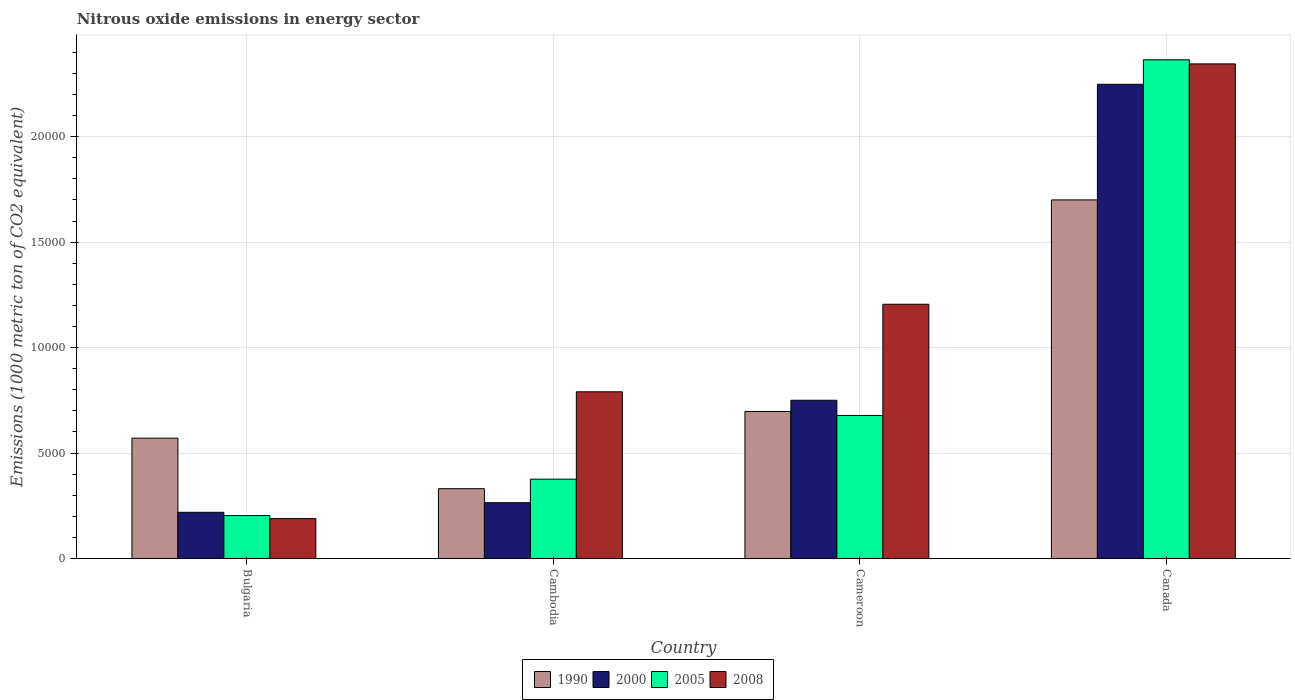Are the number of bars per tick equal to the number of legend labels?
Provide a succinct answer. Yes. How many bars are there on the 2nd tick from the right?
Give a very brief answer. 4. What is the amount of nitrous oxide emitted in 1990 in Bulgaria?
Provide a short and direct response. 5705.4. Across all countries, what is the maximum amount of nitrous oxide emitted in 2005?
Provide a succinct answer. 2.36e+04. Across all countries, what is the minimum amount of nitrous oxide emitted in 2008?
Ensure brevity in your answer.  1890.6. In which country was the amount of nitrous oxide emitted in 2008 maximum?
Your answer should be very brief. Canada. In which country was the amount of nitrous oxide emitted in 2000 minimum?
Give a very brief answer. Bulgaria. What is the total amount of nitrous oxide emitted in 2005 in the graph?
Your answer should be compact. 3.62e+04. What is the difference between the amount of nitrous oxide emitted in 1990 in Bulgaria and that in Canada?
Provide a short and direct response. -1.13e+04. What is the difference between the amount of nitrous oxide emitted in 2005 in Cameroon and the amount of nitrous oxide emitted in 2008 in Cambodia?
Provide a short and direct response. -1120.8. What is the average amount of nitrous oxide emitted in 1990 per country?
Make the answer very short. 8246.02. What is the difference between the amount of nitrous oxide emitted of/in 2005 and amount of nitrous oxide emitted of/in 2008 in Cameroon?
Give a very brief answer. -5271. What is the ratio of the amount of nitrous oxide emitted in 2000 in Bulgaria to that in Canada?
Your answer should be very brief. 0.1. What is the difference between the highest and the second highest amount of nitrous oxide emitted in 2008?
Your response must be concise. 1.14e+04. What is the difference between the highest and the lowest amount of nitrous oxide emitted in 1990?
Offer a very short reply. 1.37e+04. Is it the case that in every country, the sum of the amount of nitrous oxide emitted in 2000 and amount of nitrous oxide emitted in 2008 is greater than the sum of amount of nitrous oxide emitted in 2005 and amount of nitrous oxide emitted in 1990?
Give a very brief answer. No. What does the 1st bar from the left in Cambodia represents?
Keep it short and to the point. 1990. Is it the case that in every country, the sum of the amount of nitrous oxide emitted in 2008 and amount of nitrous oxide emitted in 2000 is greater than the amount of nitrous oxide emitted in 2005?
Provide a succinct answer. Yes. How many bars are there?
Your answer should be very brief. 16. Are all the bars in the graph horizontal?
Keep it short and to the point. No. How many countries are there in the graph?
Make the answer very short. 4. Are the values on the major ticks of Y-axis written in scientific E-notation?
Ensure brevity in your answer.  No. Does the graph contain any zero values?
Offer a very short reply. No. Does the graph contain grids?
Your answer should be very brief. Yes. Where does the legend appear in the graph?
Provide a short and direct response. Bottom center. How many legend labels are there?
Keep it short and to the point. 4. How are the legend labels stacked?
Give a very brief answer. Horizontal. What is the title of the graph?
Keep it short and to the point. Nitrous oxide emissions in energy sector. What is the label or title of the X-axis?
Give a very brief answer. Country. What is the label or title of the Y-axis?
Make the answer very short. Emissions (1000 metric ton of CO2 equivalent). What is the Emissions (1000 metric ton of CO2 equivalent) in 1990 in Bulgaria?
Offer a terse response. 5705.4. What is the Emissions (1000 metric ton of CO2 equivalent) in 2000 in Bulgaria?
Your answer should be compact. 2189.9. What is the Emissions (1000 metric ton of CO2 equivalent) in 2005 in Bulgaria?
Provide a short and direct response. 2033.5. What is the Emissions (1000 metric ton of CO2 equivalent) in 2008 in Bulgaria?
Give a very brief answer. 1890.6. What is the Emissions (1000 metric ton of CO2 equivalent) of 1990 in Cambodia?
Your response must be concise. 3309.2. What is the Emissions (1000 metric ton of CO2 equivalent) in 2000 in Cambodia?
Your answer should be very brief. 2644.9. What is the Emissions (1000 metric ton of CO2 equivalent) in 2005 in Cambodia?
Make the answer very short. 3761.1. What is the Emissions (1000 metric ton of CO2 equivalent) of 2008 in Cambodia?
Offer a terse response. 7902.7. What is the Emissions (1000 metric ton of CO2 equivalent) in 1990 in Cameroon?
Your answer should be compact. 6970.1. What is the Emissions (1000 metric ton of CO2 equivalent) in 2000 in Cameroon?
Your response must be concise. 7501.6. What is the Emissions (1000 metric ton of CO2 equivalent) of 2005 in Cameroon?
Provide a succinct answer. 6781.9. What is the Emissions (1000 metric ton of CO2 equivalent) in 2008 in Cameroon?
Keep it short and to the point. 1.21e+04. What is the Emissions (1000 metric ton of CO2 equivalent) of 1990 in Canada?
Your response must be concise. 1.70e+04. What is the Emissions (1000 metric ton of CO2 equivalent) of 2000 in Canada?
Your answer should be compact. 2.25e+04. What is the Emissions (1000 metric ton of CO2 equivalent) of 2005 in Canada?
Make the answer very short. 2.36e+04. What is the Emissions (1000 metric ton of CO2 equivalent) of 2008 in Canada?
Provide a succinct answer. 2.34e+04. Across all countries, what is the maximum Emissions (1000 metric ton of CO2 equivalent) of 1990?
Make the answer very short. 1.70e+04. Across all countries, what is the maximum Emissions (1000 metric ton of CO2 equivalent) of 2000?
Offer a terse response. 2.25e+04. Across all countries, what is the maximum Emissions (1000 metric ton of CO2 equivalent) of 2005?
Give a very brief answer. 2.36e+04. Across all countries, what is the maximum Emissions (1000 metric ton of CO2 equivalent) of 2008?
Give a very brief answer. 2.34e+04. Across all countries, what is the minimum Emissions (1000 metric ton of CO2 equivalent) in 1990?
Give a very brief answer. 3309.2. Across all countries, what is the minimum Emissions (1000 metric ton of CO2 equivalent) in 2000?
Your response must be concise. 2189.9. Across all countries, what is the minimum Emissions (1000 metric ton of CO2 equivalent) in 2005?
Your answer should be very brief. 2033.5. Across all countries, what is the minimum Emissions (1000 metric ton of CO2 equivalent) in 2008?
Make the answer very short. 1890.6. What is the total Emissions (1000 metric ton of CO2 equivalent) of 1990 in the graph?
Your answer should be compact. 3.30e+04. What is the total Emissions (1000 metric ton of CO2 equivalent) in 2000 in the graph?
Your response must be concise. 3.48e+04. What is the total Emissions (1000 metric ton of CO2 equivalent) in 2005 in the graph?
Ensure brevity in your answer.  3.62e+04. What is the total Emissions (1000 metric ton of CO2 equivalent) in 2008 in the graph?
Make the answer very short. 4.53e+04. What is the difference between the Emissions (1000 metric ton of CO2 equivalent) of 1990 in Bulgaria and that in Cambodia?
Your answer should be very brief. 2396.2. What is the difference between the Emissions (1000 metric ton of CO2 equivalent) in 2000 in Bulgaria and that in Cambodia?
Your answer should be compact. -455. What is the difference between the Emissions (1000 metric ton of CO2 equivalent) in 2005 in Bulgaria and that in Cambodia?
Keep it short and to the point. -1727.6. What is the difference between the Emissions (1000 metric ton of CO2 equivalent) in 2008 in Bulgaria and that in Cambodia?
Provide a succinct answer. -6012.1. What is the difference between the Emissions (1000 metric ton of CO2 equivalent) in 1990 in Bulgaria and that in Cameroon?
Your answer should be very brief. -1264.7. What is the difference between the Emissions (1000 metric ton of CO2 equivalent) in 2000 in Bulgaria and that in Cameroon?
Give a very brief answer. -5311.7. What is the difference between the Emissions (1000 metric ton of CO2 equivalent) in 2005 in Bulgaria and that in Cameroon?
Keep it short and to the point. -4748.4. What is the difference between the Emissions (1000 metric ton of CO2 equivalent) of 2008 in Bulgaria and that in Cameroon?
Your answer should be very brief. -1.02e+04. What is the difference between the Emissions (1000 metric ton of CO2 equivalent) of 1990 in Bulgaria and that in Canada?
Keep it short and to the point. -1.13e+04. What is the difference between the Emissions (1000 metric ton of CO2 equivalent) in 2000 in Bulgaria and that in Canada?
Your answer should be compact. -2.03e+04. What is the difference between the Emissions (1000 metric ton of CO2 equivalent) in 2005 in Bulgaria and that in Canada?
Offer a very short reply. -2.16e+04. What is the difference between the Emissions (1000 metric ton of CO2 equivalent) in 2008 in Bulgaria and that in Canada?
Your answer should be very brief. -2.16e+04. What is the difference between the Emissions (1000 metric ton of CO2 equivalent) in 1990 in Cambodia and that in Cameroon?
Offer a terse response. -3660.9. What is the difference between the Emissions (1000 metric ton of CO2 equivalent) of 2000 in Cambodia and that in Cameroon?
Make the answer very short. -4856.7. What is the difference between the Emissions (1000 metric ton of CO2 equivalent) of 2005 in Cambodia and that in Cameroon?
Keep it short and to the point. -3020.8. What is the difference between the Emissions (1000 metric ton of CO2 equivalent) of 2008 in Cambodia and that in Cameroon?
Give a very brief answer. -4150.2. What is the difference between the Emissions (1000 metric ton of CO2 equivalent) of 1990 in Cambodia and that in Canada?
Provide a short and direct response. -1.37e+04. What is the difference between the Emissions (1000 metric ton of CO2 equivalent) in 2000 in Cambodia and that in Canada?
Your answer should be very brief. -1.98e+04. What is the difference between the Emissions (1000 metric ton of CO2 equivalent) of 2005 in Cambodia and that in Canada?
Offer a very short reply. -1.99e+04. What is the difference between the Emissions (1000 metric ton of CO2 equivalent) of 2008 in Cambodia and that in Canada?
Offer a very short reply. -1.55e+04. What is the difference between the Emissions (1000 metric ton of CO2 equivalent) of 1990 in Cameroon and that in Canada?
Your response must be concise. -1.00e+04. What is the difference between the Emissions (1000 metric ton of CO2 equivalent) in 2000 in Cameroon and that in Canada?
Offer a terse response. -1.50e+04. What is the difference between the Emissions (1000 metric ton of CO2 equivalent) in 2005 in Cameroon and that in Canada?
Your answer should be compact. -1.69e+04. What is the difference between the Emissions (1000 metric ton of CO2 equivalent) of 2008 in Cameroon and that in Canada?
Ensure brevity in your answer.  -1.14e+04. What is the difference between the Emissions (1000 metric ton of CO2 equivalent) of 1990 in Bulgaria and the Emissions (1000 metric ton of CO2 equivalent) of 2000 in Cambodia?
Your response must be concise. 3060.5. What is the difference between the Emissions (1000 metric ton of CO2 equivalent) of 1990 in Bulgaria and the Emissions (1000 metric ton of CO2 equivalent) of 2005 in Cambodia?
Give a very brief answer. 1944.3. What is the difference between the Emissions (1000 metric ton of CO2 equivalent) of 1990 in Bulgaria and the Emissions (1000 metric ton of CO2 equivalent) of 2008 in Cambodia?
Offer a very short reply. -2197.3. What is the difference between the Emissions (1000 metric ton of CO2 equivalent) of 2000 in Bulgaria and the Emissions (1000 metric ton of CO2 equivalent) of 2005 in Cambodia?
Offer a very short reply. -1571.2. What is the difference between the Emissions (1000 metric ton of CO2 equivalent) of 2000 in Bulgaria and the Emissions (1000 metric ton of CO2 equivalent) of 2008 in Cambodia?
Make the answer very short. -5712.8. What is the difference between the Emissions (1000 metric ton of CO2 equivalent) of 2005 in Bulgaria and the Emissions (1000 metric ton of CO2 equivalent) of 2008 in Cambodia?
Your answer should be compact. -5869.2. What is the difference between the Emissions (1000 metric ton of CO2 equivalent) in 1990 in Bulgaria and the Emissions (1000 metric ton of CO2 equivalent) in 2000 in Cameroon?
Make the answer very short. -1796.2. What is the difference between the Emissions (1000 metric ton of CO2 equivalent) in 1990 in Bulgaria and the Emissions (1000 metric ton of CO2 equivalent) in 2005 in Cameroon?
Your answer should be compact. -1076.5. What is the difference between the Emissions (1000 metric ton of CO2 equivalent) of 1990 in Bulgaria and the Emissions (1000 metric ton of CO2 equivalent) of 2008 in Cameroon?
Ensure brevity in your answer.  -6347.5. What is the difference between the Emissions (1000 metric ton of CO2 equivalent) in 2000 in Bulgaria and the Emissions (1000 metric ton of CO2 equivalent) in 2005 in Cameroon?
Your answer should be compact. -4592. What is the difference between the Emissions (1000 metric ton of CO2 equivalent) of 2000 in Bulgaria and the Emissions (1000 metric ton of CO2 equivalent) of 2008 in Cameroon?
Keep it short and to the point. -9863. What is the difference between the Emissions (1000 metric ton of CO2 equivalent) of 2005 in Bulgaria and the Emissions (1000 metric ton of CO2 equivalent) of 2008 in Cameroon?
Offer a very short reply. -1.00e+04. What is the difference between the Emissions (1000 metric ton of CO2 equivalent) of 1990 in Bulgaria and the Emissions (1000 metric ton of CO2 equivalent) of 2000 in Canada?
Provide a short and direct response. -1.68e+04. What is the difference between the Emissions (1000 metric ton of CO2 equivalent) in 1990 in Bulgaria and the Emissions (1000 metric ton of CO2 equivalent) in 2005 in Canada?
Provide a succinct answer. -1.79e+04. What is the difference between the Emissions (1000 metric ton of CO2 equivalent) in 1990 in Bulgaria and the Emissions (1000 metric ton of CO2 equivalent) in 2008 in Canada?
Your answer should be very brief. -1.77e+04. What is the difference between the Emissions (1000 metric ton of CO2 equivalent) of 2000 in Bulgaria and the Emissions (1000 metric ton of CO2 equivalent) of 2005 in Canada?
Your answer should be compact. -2.15e+04. What is the difference between the Emissions (1000 metric ton of CO2 equivalent) of 2000 in Bulgaria and the Emissions (1000 metric ton of CO2 equivalent) of 2008 in Canada?
Keep it short and to the point. -2.13e+04. What is the difference between the Emissions (1000 metric ton of CO2 equivalent) of 2005 in Bulgaria and the Emissions (1000 metric ton of CO2 equivalent) of 2008 in Canada?
Your answer should be compact. -2.14e+04. What is the difference between the Emissions (1000 metric ton of CO2 equivalent) of 1990 in Cambodia and the Emissions (1000 metric ton of CO2 equivalent) of 2000 in Cameroon?
Your answer should be very brief. -4192.4. What is the difference between the Emissions (1000 metric ton of CO2 equivalent) in 1990 in Cambodia and the Emissions (1000 metric ton of CO2 equivalent) in 2005 in Cameroon?
Make the answer very short. -3472.7. What is the difference between the Emissions (1000 metric ton of CO2 equivalent) of 1990 in Cambodia and the Emissions (1000 metric ton of CO2 equivalent) of 2008 in Cameroon?
Make the answer very short. -8743.7. What is the difference between the Emissions (1000 metric ton of CO2 equivalent) of 2000 in Cambodia and the Emissions (1000 metric ton of CO2 equivalent) of 2005 in Cameroon?
Keep it short and to the point. -4137. What is the difference between the Emissions (1000 metric ton of CO2 equivalent) of 2000 in Cambodia and the Emissions (1000 metric ton of CO2 equivalent) of 2008 in Cameroon?
Offer a very short reply. -9408. What is the difference between the Emissions (1000 metric ton of CO2 equivalent) of 2005 in Cambodia and the Emissions (1000 metric ton of CO2 equivalent) of 2008 in Cameroon?
Your response must be concise. -8291.8. What is the difference between the Emissions (1000 metric ton of CO2 equivalent) of 1990 in Cambodia and the Emissions (1000 metric ton of CO2 equivalent) of 2000 in Canada?
Provide a short and direct response. -1.92e+04. What is the difference between the Emissions (1000 metric ton of CO2 equivalent) in 1990 in Cambodia and the Emissions (1000 metric ton of CO2 equivalent) in 2005 in Canada?
Provide a succinct answer. -2.03e+04. What is the difference between the Emissions (1000 metric ton of CO2 equivalent) of 1990 in Cambodia and the Emissions (1000 metric ton of CO2 equivalent) of 2008 in Canada?
Your answer should be very brief. -2.01e+04. What is the difference between the Emissions (1000 metric ton of CO2 equivalent) in 2000 in Cambodia and the Emissions (1000 metric ton of CO2 equivalent) in 2005 in Canada?
Your answer should be compact. -2.10e+04. What is the difference between the Emissions (1000 metric ton of CO2 equivalent) of 2000 in Cambodia and the Emissions (1000 metric ton of CO2 equivalent) of 2008 in Canada?
Provide a short and direct response. -2.08e+04. What is the difference between the Emissions (1000 metric ton of CO2 equivalent) in 2005 in Cambodia and the Emissions (1000 metric ton of CO2 equivalent) in 2008 in Canada?
Your answer should be compact. -1.97e+04. What is the difference between the Emissions (1000 metric ton of CO2 equivalent) of 1990 in Cameroon and the Emissions (1000 metric ton of CO2 equivalent) of 2000 in Canada?
Give a very brief answer. -1.55e+04. What is the difference between the Emissions (1000 metric ton of CO2 equivalent) of 1990 in Cameroon and the Emissions (1000 metric ton of CO2 equivalent) of 2005 in Canada?
Give a very brief answer. -1.67e+04. What is the difference between the Emissions (1000 metric ton of CO2 equivalent) of 1990 in Cameroon and the Emissions (1000 metric ton of CO2 equivalent) of 2008 in Canada?
Give a very brief answer. -1.65e+04. What is the difference between the Emissions (1000 metric ton of CO2 equivalent) of 2000 in Cameroon and the Emissions (1000 metric ton of CO2 equivalent) of 2005 in Canada?
Make the answer very short. -1.61e+04. What is the difference between the Emissions (1000 metric ton of CO2 equivalent) in 2000 in Cameroon and the Emissions (1000 metric ton of CO2 equivalent) in 2008 in Canada?
Ensure brevity in your answer.  -1.59e+04. What is the difference between the Emissions (1000 metric ton of CO2 equivalent) in 2005 in Cameroon and the Emissions (1000 metric ton of CO2 equivalent) in 2008 in Canada?
Keep it short and to the point. -1.67e+04. What is the average Emissions (1000 metric ton of CO2 equivalent) of 1990 per country?
Make the answer very short. 8246.02. What is the average Emissions (1000 metric ton of CO2 equivalent) in 2000 per country?
Provide a short and direct response. 8704.3. What is the average Emissions (1000 metric ton of CO2 equivalent) of 2005 per country?
Make the answer very short. 9054.62. What is the average Emissions (1000 metric ton of CO2 equivalent) in 2008 per country?
Your answer should be very brief. 1.13e+04. What is the difference between the Emissions (1000 metric ton of CO2 equivalent) of 1990 and Emissions (1000 metric ton of CO2 equivalent) of 2000 in Bulgaria?
Keep it short and to the point. 3515.5. What is the difference between the Emissions (1000 metric ton of CO2 equivalent) of 1990 and Emissions (1000 metric ton of CO2 equivalent) of 2005 in Bulgaria?
Provide a short and direct response. 3671.9. What is the difference between the Emissions (1000 metric ton of CO2 equivalent) in 1990 and Emissions (1000 metric ton of CO2 equivalent) in 2008 in Bulgaria?
Offer a very short reply. 3814.8. What is the difference between the Emissions (1000 metric ton of CO2 equivalent) of 2000 and Emissions (1000 metric ton of CO2 equivalent) of 2005 in Bulgaria?
Offer a very short reply. 156.4. What is the difference between the Emissions (1000 metric ton of CO2 equivalent) in 2000 and Emissions (1000 metric ton of CO2 equivalent) in 2008 in Bulgaria?
Your answer should be very brief. 299.3. What is the difference between the Emissions (1000 metric ton of CO2 equivalent) in 2005 and Emissions (1000 metric ton of CO2 equivalent) in 2008 in Bulgaria?
Make the answer very short. 142.9. What is the difference between the Emissions (1000 metric ton of CO2 equivalent) in 1990 and Emissions (1000 metric ton of CO2 equivalent) in 2000 in Cambodia?
Offer a terse response. 664.3. What is the difference between the Emissions (1000 metric ton of CO2 equivalent) in 1990 and Emissions (1000 metric ton of CO2 equivalent) in 2005 in Cambodia?
Make the answer very short. -451.9. What is the difference between the Emissions (1000 metric ton of CO2 equivalent) in 1990 and Emissions (1000 metric ton of CO2 equivalent) in 2008 in Cambodia?
Your answer should be compact. -4593.5. What is the difference between the Emissions (1000 metric ton of CO2 equivalent) in 2000 and Emissions (1000 metric ton of CO2 equivalent) in 2005 in Cambodia?
Make the answer very short. -1116.2. What is the difference between the Emissions (1000 metric ton of CO2 equivalent) in 2000 and Emissions (1000 metric ton of CO2 equivalent) in 2008 in Cambodia?
Keep it short and to the point. -5257.8. What is the difference between the Emissions (1000 metric ton of CO2 equivalent) of 2005 and Emissions (1000 metric ton of CO2 equivalent) of 2008 in Cambodia?
Your answer should be very brief. -4141.6. What is the difference between the Emissions (1000 metric ton of CO2 equivalent) of 1990 and Emissions (1000 metric ton of CO2 equivalent) of 2000 in Cameroon?
Offer a terse response. -531.5. What is the difference between the Emissions (1000 metric ton of CO2 equivalent) of 1990 and Emissions (1000 metric ton of CO2 equivalent) of 2005 in Cameroon?
Your response must be concise. 188.2. What is the difference between the Emissions (1000 metric ton of CO2 equivalent) of 1990 and Emissions (1000 metric ton of CO2 equivalent) of 2008 in Cameroon?
Make the answer very short. -5082.8. What is the difference between the Emissions (1000 metric ton of CO2 equivalent) in 2000 and Emissions (1000 metric ton of CO2 equivalent) in 2005 in Cameroon?
Ensure brevity in your answer.  719.7. What is the difference between the Emissions (1000 metric ton of CO2 equivalent) in 2000 and Emissions (1000 metric ton of CO2 equivalent) in 2008 in Cameroon?
Provide a succinct answer. -4551.3. What is the difference between the Emissions (1000 metric ton of CO2 equivalent) of 2005 and Emissions (1000 metric ton of CO2 equivalent) of 2008 in Cameroon?
Keep it short and to the point. -5271. What is the difference between the Emissions (1000 metric ton of CO2 equivalent) of 1990 and Emissions (1000 metric ton of CO2 equivalent) of 2000 in Canada?
Ensure brevity in your answer.  -5481.4. What is the difference between the Emissions (1000 metric ton of CO2 equivalent) of 1990 and Emissions (1000 metric ton of CO2 equivalent) of 2005 in Canada?
Give a very brief answer. -6642.6. What is the difference between the Emissions (1000 metric ton of CO2 equivalent) in 1990 and Emissions (1000 metric ton of CO2 equivalent) in 2008 in Canada?
Keep it short and to the point. -6448.9. What is the difference between the Emissions (1000 metric ton of CO2 equivalent) of 2000 and Emissions (1000 metric ton of CO2 equivalent) of 2005 in Canada?
Provide a succinct answer. -1161.2. What is the difference between the Emissions (1000 metric ton of CO2 equivalent) in 2000 and Emissions (1000 metric ton of CO2 equivalent) in 2008 in Canada?
Ensure brevity in your answer.  -967.5. What is the difference between the Emissions (1000 metric ton of CO2 equivalent) of 2005 and Emissions (1000 metric ton of CO2 equivalent) of 2008 in Canada?
Give a very brief answer. 193.7. What is the ratio of the Emissions (1000 metric ton of CO2 equivalent) in 1990 in Bulgaria to that in Cambodia?
Offer a very short reply. 1.72. What is the ratio of the Emissions (1000 metric ton of CO2 equivalent) of 2000 in Bulgaria to that in Cambodia?
Keep it short and to the point. 0.83. What is the ratio of the Emissions (1000 metric ton of CO2 equivalent) of 2005 in Bulgaria to that in Cambodia?
Your answer should be compact. 0.54. What is the ratio of the Emissions (1000 metric ton of CO2 equivalent) in 2008 in Bulgaria to that in Cambodia?
Your response must be concise. 0.24. What is the ratio of the Emissions (1000 metric ton of CO2 equivalent) in 1990 in Bulgaria to that in Cameroon?
Offer a terse response. 0.82. What is the ratio of the Emissions (1000 metric ton of CO2 equivalent) of 2000 in Bulgaria to that in Cameroon?
Ensure brevity in your answer.  0.29. What is the ratio of the Emissions (1000 metric ton of CO2 equivalent) of 2005 in Bulgaria to that in Cameroon?
Your answer should be very brief. 0.3. What is the ratio of the Emissions (1000 metric ton of CO2 equivalent) in 2008 in Bulgaria to that in Cameroon?
Offer a terse response. 0.16. What is the ratio of the Emissions (1000 metric ton of CO2 equivalent) of 1990 in Bulgaria to that in Canada?
Ensure brevity in your answer.  0.34. What is the ratio of the Emissions (1000 metric ton of CO2 equivalent) in 2000 in Bulgaria to that in Canada?
Offer a terse response. 0.1. What is the ratio of the Emissions (1000 metric ton of CO2 equivalent) in 2005 in Bulgaria to that in Canada?
Your answer should be compact. 0.09. What is the ratio of the Emissions (1000 metric ton of CO2 equivalent) in 2008 in Bulgaria to that in Canada?
Your answer should be compact. 0.08. What is the ratio of the Emissions (1000 metric ton of CO2 equivalent) of 1990 in Cambodia to that in Cameroon?
Keep it short and to the point. 0.47. What is the ratio of the Emissions (1000 metric ton of CO2 equivalent) of 2000 in Cambodia to that in Cameroon?
Your response must be concise. 0.35. What is the ratio of the Emissions (1000 metric ton of CO2 equivalent) in 2005 in Cambodia to that in Cameroon?
Your answer should be very brief. 0.55. What is the ratio of the Emissions (1000 metric ton of CO2 equivalent) in 2008 in Cambodia to that in Cameroon?
Provide a short and direct response. 0.66. What is the ratio of the Emissions (1000 metric ton of CO2 equivalent) of 1990 in Cambodia to that in Canada?
Give a very brief answer. 0.19. What is the ratio of the Emissions (1000 metric ton of CO2 equivalent) of 2000 in Cambodia to that in Canada?
Ensure brevity in your answer.  0.12. What is the ratio of the Emissions (1000 metric ton of CO2 equivalent) in 2005 in Cambodia to that in Canada?
Offer a very short reply. 0.16. What is the ratio of the Emissions (1000 metric ton of CO2 equivalent) of 2008 in Cambodia to that in Canada?
Provide a short and direct response. 0.34. What is the ratio of the Emissions (1000 metric ton of CO2 equivalent) of 1990 in Cameroon to that in Canada?
Provide a short and direct response. 0.41. What is the ratio of the Emissions (1000 metric ton of CO2 equivalent) of 2000 in Cameroon to that in Canada?
Your response must be concise. 0.33. What is the ratio of the Emissions (1000 metric ton of CO2 equivalent) in 2005 in Cameroon to that in Canada?
Offer a very short reply. 0.29. What is the ratio of the Emissions (1000 metric ton of CO2 equivalent) in 2008 in Cameroon to that in Canada?
Offer a very short reply. 0.51. What is the difference between the highest and the second highest Emissions (1000 metric ton of CO2 equivalent) of 1990?
Your answer should be very brief. 1.00e+04. What is the difference between the highest and the second highest Emissions (1000 metric ton of CO2 equivalent) of 2000?
Your answer should be very brief. 1.50e+04. What is the difference between the highest and the second highest Emissions (1000 metric ton of CO2 equivalent) of 2005?
Your answer should be very brief. 1.69e+04. What is the difference between the highest and the second highest Emissions (1000 metric ton of CO2 equivalent) in 2008?
Give a very brief answer. 1.14e+04. What is the difference between the highest and the lowest Emissions (1000 metric ton of CO2 equivalent) of 1990?
Your response must be concise. 1.37e+04. What is the difference between the highest and the lowest Emissions (1000 metric ton of CO2 equivalent) in 2000?
Ensure brevity in your answer.  2.03e+04. What is the difference between the highest and the lowest Emissions (1000 metric ton of CO2 equivalent) in 2005?
Your response must be concise. 2.16e+04. What is the difference between the highest and the lowest Emissions (1000 metric ton of CO2 equivalent) in 2008?
Offer a very short reply. 2.16e+04. 